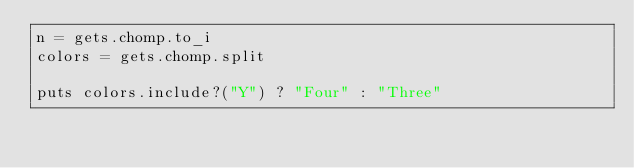Convert code to text. <code><loc_0><loc_0><loc_500><loc_500><_Ruby_>n = gets.chomp.to_i
colors = gets.chomp.split

puts colors.include?("Y") ? "Four" : "Three"
</code> 